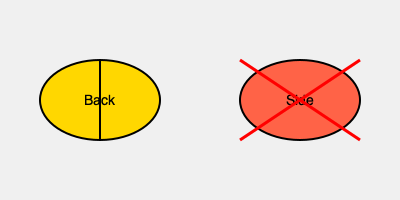Based on the diagram, which sleeping position is recommended for newborns, and why is the other position not advised? 1. The diagram shows two sleeping positions for newborns: back and side.

2. The back sleeping position is represented by a yellow ellipse, which typically indicates a positive or recommended action.

3. The side sleeping position is shown in red and has a red "X" drawn over it, suggesting this position is not recommended.

4. Back sleeping is recommended for newborns because:
   a. It reduces the risk of Sudden Infant Death Syndrome (SIDS).
   b. It helps maintain a clear airway for breathing.
   c. It prevents the baby from rolling onto their stomach, which can be dangerous.

5. Side sleeping is not advised because:
   a. It increases the risk of SIDS.
   b. Babies may roll onto their stomachs from this position, which is unsafe.
   c. It can lead to positional plagiocephaly (flat head syndrome).

6. The American Academy of Pediatrics (AAP) recommends placing babies on their backs to sleep for every sleep, both at night and for naps.
Answer: Back sleeping is recommended; side sleeping increases SIDS risk. 